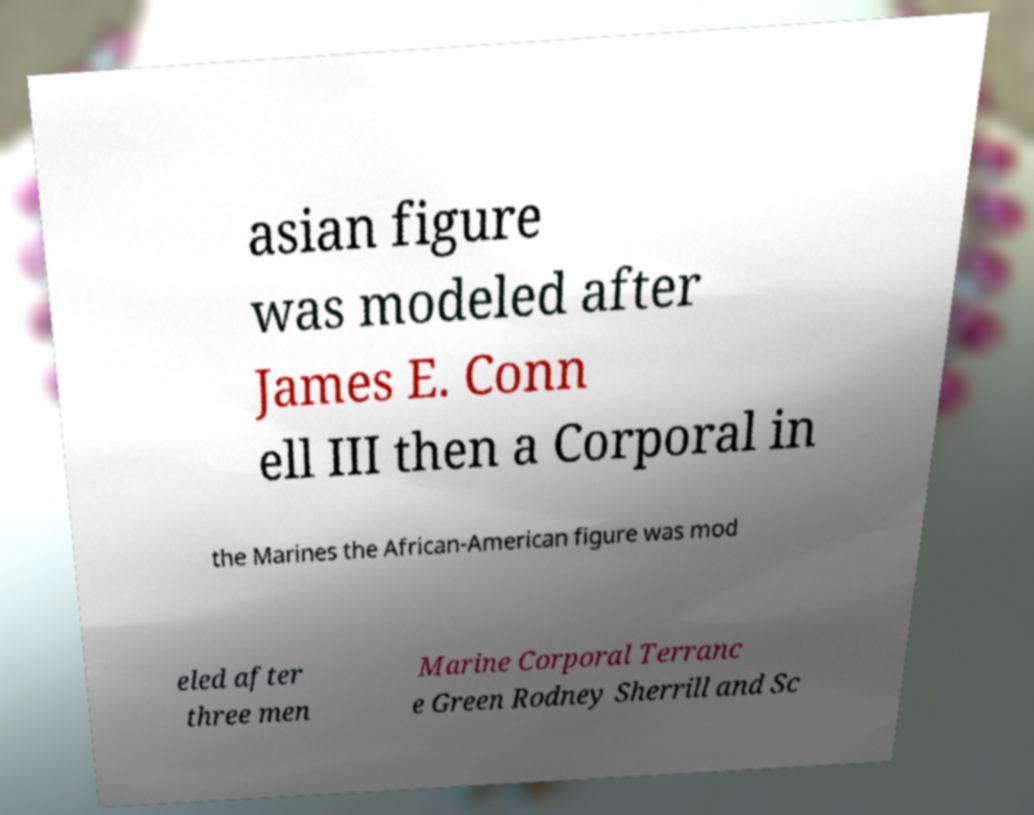Can you read and provide the text displayed in the image?This photo seems to have some interesting text. Can you extract and type it out for me? asian figure was modeled after James E. Conn ell III then a Corporal in the Marines the African-American figure was mod eled after three men Marine Corporal Terranc e Green Rodney Sherrill and Sc 